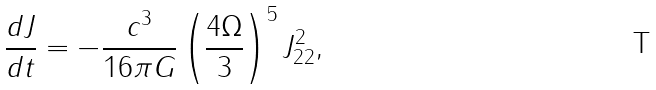<formula> <loc_0><loc_0><loc_500><loc_500>\frac { d J } { d t } = - \frac { c ^ { 3 } } { 1 6 \pi G } \left ( \frac { 4 \Omega } { 3 } \right ) ^ { 5 } J _ { 2 2 } ^ { 2 } ,</formula> 